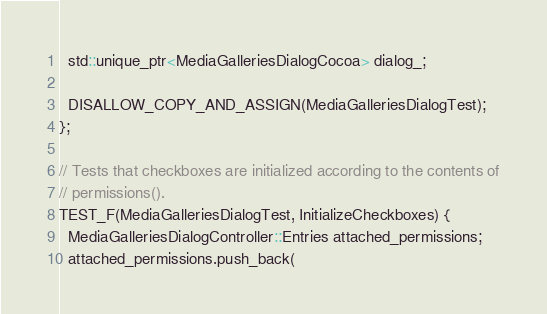Convert code to text. <code><loc_0><loc_0><loc_500><loc_500><_ObjectiveC_>  std::unique_ptr<MediaGalleriesDialogCocoa> dialog_;

  DISALLOW_COPY_AND_ASSIGN(MediaGalleriesDialogTest);
};

// Tests that checkboxes are initialized according to the contents of
// permissions().
TEST_F(MediaGalleriesDialogTest, InitializeCheckboxes) {
  MediaGalleriesDialogController::Entries attached_permissions;
  attached_permissions.push_back(</code> 